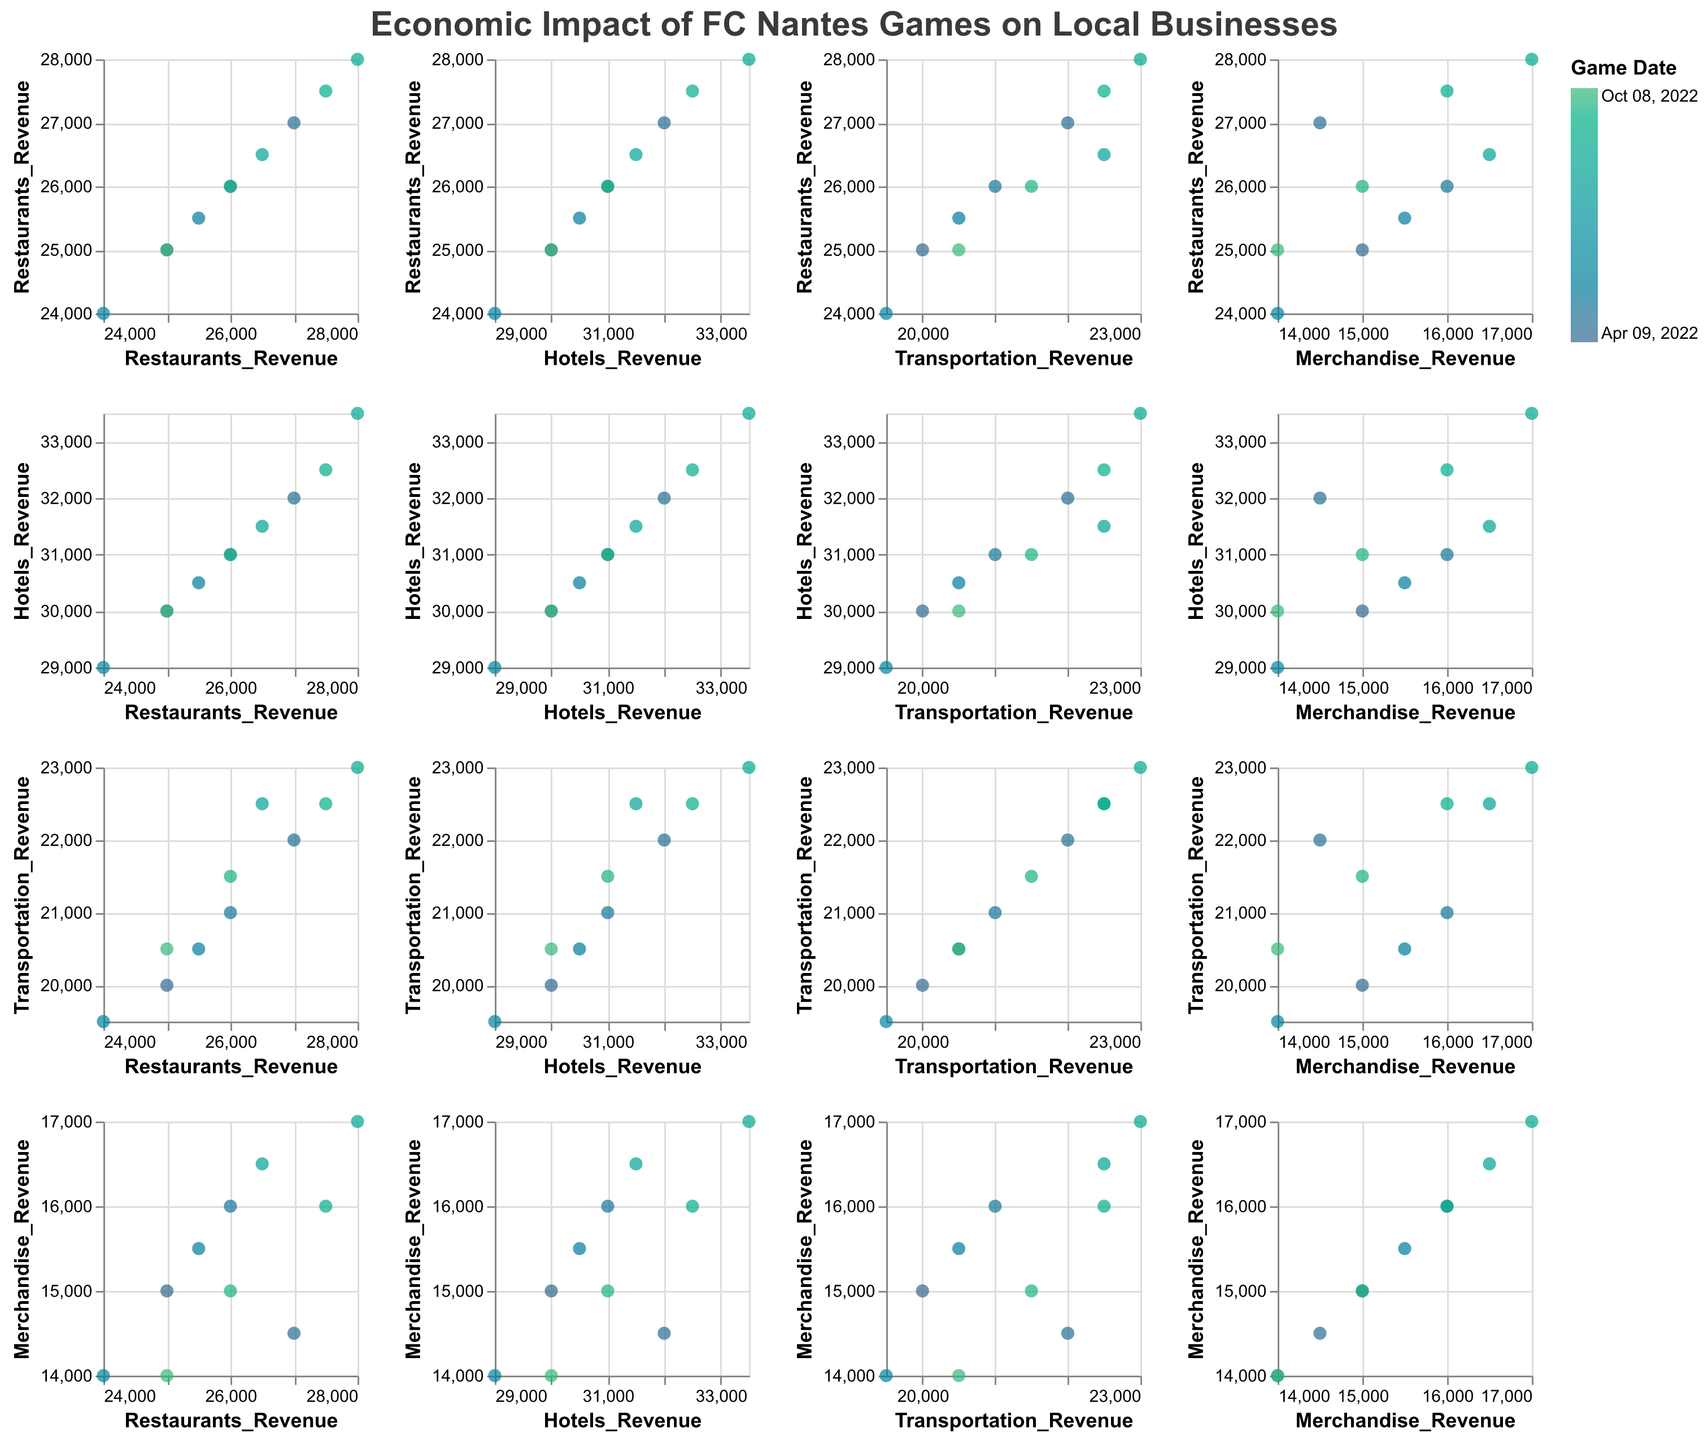What is the title of the figure? The title of the figure is typically shown at the top of the chart. In this case, it is prominently displayed using a larger and bold font.
Answer: Economic Impact of FC Nantes Games on Local Businesses How many different revenue categories are being compared? The categories are indicated by the scatter plots across different columns and rows. Observing the labels, we see that the categories are ‘Restaurants Revenue’, ‘Hotels Revenue’, ‘Transportation Revenue’, and ‘Merchandise Revenue’.
Answer: 4 Which pair of categories has the strongest positive correlation in the scatter plot matrix? By visually inspecting the scatter plots, we look for pairs that show points forming a tight, upward-sloping cluster. The scatter plot pairs involving 'Restaurants Revenue' and 'Hotels Revenue' seem to have the strongest positive correlation.
Answer: Restaurants Revenue and Hotels Revenue What does the color of the points represent in the figure? The color of the points is explained in the legend and varies based on some time-related variable. Here it indicates the game dates, with different shades representing different matches.
Answer: Game dates Which game date might correlate with the highest revenues across all categories? To answer this, we observe the brightest or most intense color points throughout the scatter plots. The brightest points, most consistently at the upper right corners, can indicate the game date with the highest revenues.
Answer: 2022-08-28 Is there any category that shows no apparent correlation with any other category? We look at the scatter plots for clusters that seem randomly scattered without a definite slope. The scatter plots involving 'Merchandise Revenue' seem to show no apparent correlation with other categories.
Answer: Merchandise Revenue On which game date did the revenues from 'Transportation' and 'Restaurants' have similar values? Similar values would appear close to the diagonal line where y = x. Checking for this scenario, it appears most closely on the 'Transportation vs. Restaurants' scatter plot on the date 2022-09-11.
Answer: 2022-09-11 Are there any outliers visible in the scatter plots? Outliers are points that are significantly distant from the main cluster of points in any scatter plot. Observing all plots, there do not appear to be significant outliers for any paired categories.
Answer: No What trends can be observed from the 'Hotels Revenue' compared to 'Transportation Revenue'? Observing the scatter plots, we follow the pattern of points. There is a visible upward trend, indicating that higher 'Hotels Revenue' generally aligns with higher 'Transportation Revenue'.
Answer: Positive trend Which two game dates have the nearest values in terms of 'Restaurants Revenue'? By looking at the clusters for 'Restaurants Revenue', we find game dates that are closely aligned. Observing carefully, 2022-05-08 (26000) and 2022-09-25 (26000) have the nearest values.
Answer: 2022-05-08 and 2022-09-25 